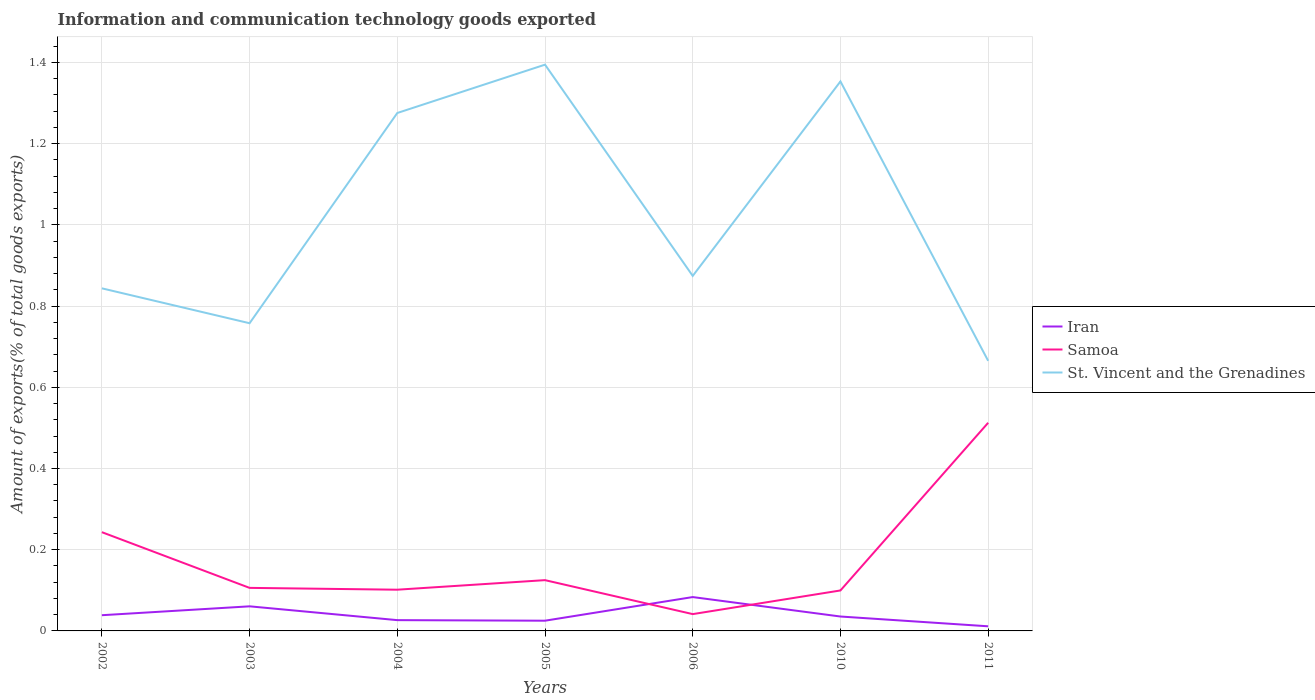How many different coloured lines are there?
Your answer should be compact. 3. Across all years, what is the maximum amount of goods exported in Samoa?
Your answer should be compact. 0.04. In which year was the amount of goods exported in Iran maximum?
Offer a terse response. 2011. What is the total amount of goods exported in St. Vincent and the Grenadines in the graph?
Offer a terse response. -0.12. What is the difference between the highest and the second highest amount of goods exported in Samoa?
Offer a terse response. 0.47. What is the difference between the highest and the lowest amount of goods exported in St. Vincent and the Grenadines?
Make the answer very short. 3. How many lines are there?
Offer a terse response. 3. How many years are there in the graph?
Give a very brief answer. 7. Are the values on the major ticks of Y-axis written in scientific E-notation?
Give a very brief answer. No. What is the title of the graph?
Your response must be concise. Information and communication technology goods exported. Does "Bermuda" appear as one of the legend labels in the graph?
Offer a very short reply. No. What is the label or title of the Y-axis?
Give a very brief answer. Amount of exports(% of total goods exports). What is the Amount of exports(% of total goods exports) of Iran in 2002?
Give a very brief answer. 0.04. What is the Amount of exports(% of total goods exports) in Samoa in 2002?
Your answer should be very brief. 0.24. What is the Amount of exports(% of total goods exports) of St. Vincent and the Grenadines in 2002?
Your answer should be very brief. 0.84. What is the Amount of exports(% of total goods exports) of Iran in 2003?
Keep it short and to the point. 0.06. What is the Amount of exports(% of total goods exports) of Samoa in 2003?
Your response must be concise. 0.11. What is the Amount of exports(% of total goods exports) of St. Vincent and the Grenadines in 2003?
Your response must be concise. 0.76. What is the Amount of exports(% of total goods exports) in Iran in 2004?
Provide a short and direct response. 0.03. What is the Amount of exports(% of total goods exports) in Samoa in 2004?
Make the answer very short. 0.1. What is the Amount of exports(% of total goods exports) in St. Vincent and the Grenadines in 2004?
Provide a short and direct response. 1.28. What is the Amount of exports(% of total goods exports) in Iran in 2005?
Make the answer very short. 0.03. What is the Amount of exports(% of total goods exports) of Samoa in 2005?
Provide a succinct answer. 0.13. What is the Amount of exports(% of total goods exports) in St. Vincent and the Grenadines in 2005?
Offer a very short reply. 1.39. What is the Amount of exports(% of total goods exports) of Iran in 2006?
Give a very brief answer. 0.08. What is the Amount of exports(% of total goods exports) in Samoa in 2006?
Provide a short and direct response. 0.04. What is the Amount of exports(% of total goods exports) in St. Vincent and the Grenadines in 2006?
Your response must be concise. 0.87. What is the Amount of exports(% of total goods exports) of Iran in 2010?
Keep it short and to the point. 0.04. What is the Amount of exports(% of total goods exports) in Samoa in 2010?
Make the answer very short. 0.1. What is the Amount of exports(% of total goods exports) of St. Vincent and the Grenadines in 2010?
Offer a very short reply. 1.35. What is the Amount of exports(% of total goods exports) of Iran in 2011?
Offer a terse response. 0.01. What is the Amount of exports(% of total goods exports) in Samoa in 2011?
Ensure brevity in your answer.  0.51. What is the Amount of exports(% of total goods exports) of St. Vincent and the Grenadines in 2011?
Offer a terse response. 0.67. Across all years, what is the maximum Amount of exports(% of total goods exports) of Iran?
Provide a short and direct response. 0.08. Across all years, what is the maximum Amount of exports(% of total goods exports) in Samoa?
Offer a terse response. 0.51. Across all years, what is the maximum Amount of exports(% of total goods exports) of St. Vincent and the Grenadines?
Give a very brief answer. 1.39. Across all years, what is the minimum Amount of exports(% of total goods exports) in Iran?
Your answer should be very brief. 0.01. Across all years, what is the minimum Amount of exports(% of total goods exports) in Samoa?
Keep it short and to the point. 0.04. Across all years, what is the minimum Amount of exports(% of total goods exports) in St. Vincent and the Grenadines?
Give a very brief answer. 0.67. What is the total Amount of exports(% of total goods exports) of Iran in the graph?
Make the answer very short. 0.28. What is the total Amount of exports(% of total goods exports) of Samoa in the graph?
Offer a terse response. 1.23. What is the total Amount of exports(% of total goods exports) in St. Vincent and the Grenadines in the graph?
Your answer should be very brief. 7.16. What is the difference between the Amount of exports(% of total goods exports) of Iran in 2002 and that in 2003?
Make the answer very short. -0.02. What is the difference between the Amount of exports(% of total goods exports) in Samoa in 2002 and that in 2003?
Provide a succinct answer. 0.14. What is the difference between the Amount of exports(% of total goods exports) in St. Vincent and the Grenadines in 2002 and that in 2003?
Offer a terse response. 0.09. What is the difference between the Amount of exports(% of total goods exports) of Iran in 2002 and that in 2004?
Your answer should be very brief. 0.01. What is the difference between the Amount of exports(% of total goods exports) of Samoa in 2002 and that in 2004?
Keep it short and to the point. 0.14. What is the difference between the Amount of exports(% of total goods exports) of St. Vincent and the Grenadines in 2002 and that in 2004?
Offer a very short reply. -0.43. What is the difference between the Amount of exports(% of total goods exports) in Iran in 2002 and that in 2005?
Give a very brief answer. 0.01. What is the difference between the Amount of exports(% of total goods exports) in Samoa in 2002 and that in 2005?
Your answer should be compact. 0.12. What is the difference between the Amount of exports(% of total goods exports) of St. Vincent and the Grenadines in 2002 and that in 2005?
Offer a terse response. -0.55. What is the difference between the Amount of exports(% of total goods exports) of Iran in 2002 and that in 2006?
Provide a short and direct response. -0.04. What is the difference between the Amount of exports(% of total goods exports) of Samoa in 2002 and that in 2006?
Your answer should be very brief. 0.2. What is the difference between the Amount of exports(% of total goods exports) in St. Vincent and the Grenadines in 2002 and that in 2006?
Offer a very short reply. -0.03. What is the difference between the Amount of exports(% of total goods exports) in Iran in 2002 and that in 2010?
Your answer should be very brief. 0. What is the difference between the Amount of exports(% of total goods exports) in Samoa in 2002 and that in 2010?
Keep it short and to the point. 0.14. What is the difference between the Amount of exports(% of total goods exports) of St. Vincent and the Grenadines in 2002 and that in 2010?
Offer a very short reply. -0.51. What is the difference between the Amount of exports(% of total goods exports) in Iran in 2002 and that in 2011?
Keep it short and to the point. 0.03. What is the difference between the Amount of exports(% of total goods exports) in Samoa in 2002 and that in 2011?
Provide a succinct answer. -0.27. What is the difference between the Amount of exports(% of total goods exports) of St. Vincent and the Grenadines in 2002 and that in 2011?
Ensure brevity in your answer.  0.18. What is the difference between the Amount of exports(% of total goods exports) in Iran in 2003 and that in 2004?
Give a very brief answer. 0.03. What is the difference between the Amount of exports(% of total goods exports) of Samoa in 2003 and that in 2004?
Your response must be concise. 0. What is the difference between the Amount of exports(% of total goods exports) in St. Vincent and the Grenadines in 2003 and that in 2004?
Provide a short and direct response. -0.52. What is the difference between the Amount of exports(% of total goods exports) of Iran in 2003 and that in 2005?
Make the answer very short. 0.04. What is the difference between the Amount of exports(% of total goods exports) of Samoa in 2003 and that in 2005?
Your answer should be very brief. -0.02. What is the difference between the Amount of exports(% of total goods exports) in St. Vincent and the Grenadines in 2003 and that in 2005?
Offer a very short reply. -0.64. What is the difference between the Amount of exports(% of total goods exports) in Iran in 2003 and that in 2006?
Ensure brevity in your answer.  -0.02. What is the difference between the Amount of exports(% of total goods exports) of Samoa in 2003 and that in 2006?
Your response must be concise. 0.06. What is the difference between the Amount of exports(% of total goods exports) of St. Vincent and the Grenadines in 2003 and that in 2006?
Keep it short and to the point. -0.12. What is the difference between the Amount of exports(% of total goods exports) in Iran in 2003 and that in 2010?
Provide a succinct answer. 0.03. What is the difference between the Amount of exports(% of total goods exports) of Samoa in 2003 and that in 2010?
Make the answer very short. 0.01. What is the difference between the Amount of exports(% of total goods exports) in St. Vincent and the Grenadines in 2003 and that in 2010?
Ensure brevity in your answer.  -0.6. What is the difference between the Amount of exports(% of total goods exports) of Iran in 2003 and that in 2011?
Give a very brief answer. 0.05. What is the difference between the Amount of exports(% of total goods exports) of Samoa in 2003 and that in 2011?
Give a very brief answer. -0.41. What is the difference between the Amount of exports(% of total goods exports) in St. Vincent and the Grenadines in 2003 and that in 2011?
Offer a terse response. 0.09. What is the difference between the Amount of exports(% of total goods exports) of Iran in 2004 and that in 2005?
Your response must be concise. 0. What is the difference between the Amount of exports(% of total goods exports) of Samoa in 2004 and that in 2005?
Give a very brief answer. -0.02. What is the difference between the Amount of exports(% of total goods exports) of St. Vincent and the Grenadines in 2004 and that in 2005?
Ensure brevity in your answer.  -0.12. What is the difference between the Amount of exports(% of total goods exports) of Iran in 2004 and that in 2006?
Give a very brief answer. -0.06. What is the difference between the Amount of exports(% of total goods exports) of Samoa in 2004 and that in 2006?
Offer a terse response. 0.06. What is the difference between the Amount of exports(% of total goods exports) of St. Vincent and the Grenadines in 2004 and that in 2006?
Keep it short and to the point. 0.4. What is the difference between the Amount of exports(% of total goods exports) in Iran in 2004 and that in 2010?
Offer a very short reply. -0.01. What is the difference between the Amount of exports(% of total goods exports) in Samoa in 2004 and that in 2010?
Your response must be concise. 0. What is the difference between the Amount of exports(% of total goods exports) in St. Vincent and the Grenadines in 2004 and that in 2010?
Ensure brevity in your answer.  -0.08. What is the difference between the Amount of exports(% of total goods exports) of Iran in 2004 and that in 2011?
Give a very brief answer. 0.02. What is the difference between the Amount of exports(% of total goods exports) in Samoa in 2004 and that in 2011?
Offer a terse response. -0.41. What is the difference between the Amount of exports(% of total goods exports) in St. Vincent and the Grenadines in 2004 and that in 2011?
Give a very brief answer. 0.61. What is the difference between the Amount of exports(% of total goods exports) in Iran in 2005 and that in 2006?
Offer a terse response. -0.06. What is the difference between the Amount of exports(% of total goods exports) of Samoa in 2005 and that in 2006?
Give a very brief answer. 0.08. What is the difference between the Amount of exports(% of total goods exports) in St. Vincent and the Grenadines in 2005 and that in 2006?
Make the answer very short. 0.52. What is the difference between the Amount of exports(% of total goods exports) of Iran in 2005 and that in 2010?
Provide a short and direct response. -0.01. What is the difference between the Amount of exports(% of total goods exports) of Samoa in 2005 and that in 2010?
Your response must be concise. 0.03. What is the difference between the Amount of exports(% of total goods exports) in St. Vincent and the Grenadines in 2005 and that in 2010?
Make the answer very short. 0.04. What is the difference between the Amount of exports(% of total goods exports) of Iran in 2005 and that in 2011?
Ensure brevity in your answer.  0.01. What is the difference between the Amount of exports(% of total goods exports) in Samoa in 2005 and that in 2011?
Keep it short and to the point. -0.39. What is the difference between the Amount of exports(% of total goods exports) of St. Vincent and the Grenadines in 2005 and that in 2011?
Your answer should be very brief. 0.73. What is the difference between the Amount of exports(% of total goods exports) of Iran in 2006 and that in 2010?
Provide a succinct answer. 0.05. What is the difference between the Amount of exports(% of total goods exports) of Samoa in 2006 and that in 2010?
Offer a terse response. -0.06. What is the difference between the Amount of exports(% of total goods exports) in St. Vincent and the Grenadines in 2006 and that in 2010?
Your answer should be compact. -0.48. What is the difference between the Amount of exports(% of total goods exports) in Iran in 2006 and that in 2011?
Your answer should be very brief. 0.07. What is the difference between the Amount of exports(% of total goods exports) in Samoa in 2006 and that in 2011?
Your answer should be compact. -0.47. What is the difference between the Amount of exports(% of total goods exports) in St. Vincent and the Grenadines in 2006 and that in 2011?
Provide a succinct answer. 0.21. What is the difference between the Amount of exports(% of total goods exports) of Iran in 2010 and that in 2011?
Offer a terse response. 0.02. What is the difference between the Amount of exports(% of total goods exports) in Samoa in 2010 and that in 2011?
Provide a short and direct response. -0.41. What is the difference between the Amount of exports(% of total goods exports) of St. Vincent and the Grenadines in 2010 and that in 2011?
Provide a short and direct response. 0.69. What is the difference between the Amount of exports(% of total goods exports) in Iran in 2002 and the Amount of exports(% of total goods exports) in Samoa in 2003?
Your response must be concise. -0.07. What is the difference between the Amount of exports(% of total goods exports) in Iran in 2002 and the Amount of exports(% of total goods exports) in St. Vincent and the Grenadines in 2003?
Provide a short and direct response. -0.72. What is the difference between the Amount of exports(% of total goods exports) in Samoa in 2002 and the Amount of exports(% of total goods exports) in St. Vincent and the Grenadines in 2003?
Ensure brevity in your answer.  -0.51. What is the difference between the Amount of exports(% of total goods exports) of Iran in 2002 and the Amount of exports(% of total goods exports) of Samoa in 2004?
Offer a terse response. -0.06. What is the difference between the Amount of exports(% of total goods exports) of Iran in 2002 and the Amount of exports(% of total goods exports) of St. Vincent and the Grenadines in 2004?
Keep it short and to the point. -1.24. What is the difference between the Amount of exports(% of total goods exports) in Samoa in 2002 and the Amount of exports(% of total goods exports) in St. Vincent and the Grenadines in 2004?
Offer a very short reply. -1.03. What is the difference between the Amount of exports(% of total goods exports) in Iran in 2002 and the Amount of exports(% of total goods exports) in Samoa in 2005?
Your answer should be very brief. -0.09. What is the difference between the Amount of exports(% of total goods exports) of Iran in 2002 and the Amount of exports(% of total goods exports) of St. Vincent and the Grenadines in 2005?
Provide a succinct answer. -1.36. What is the difference between the Amount of exports(% of total goods exports) of Samoa in 2002 and the Amount of exports(% of total goods exports) of St. Vincent and the Grenadines in 2005?
Ensure brevity in your answer.  -1.15. What is the difference between the Amount of exports(% of total goods exports) of Iran in 2002 and the Amount of exports(% of total goods exports) of Samoa in 2006?
Provide a succinct answer. -0. What is the difference between the Amount of exports(% of total goods exports) of Iran in 2002 and the Amount of exports(% of total goods exports) of St. Vincent and the Grenadines in 2006?
Offer a very short reply. -0.84. What is the difference between the Amount of exports(% of total goods exports) in Samoa in 2002 and the Amount of exports(% of total goods exports) in St. Vincent and the Grenadines in 2006?
Give a very brief answer. -0.63. What is the difference between the Amount of exports(% of total goods exports) in Iran in 2002 and the Amount of exports(% of total goods exports) in Samoa in 2010?
Ensure brevity in your answer.  -0.06. What is the difference between the Amount of exports(% of total goods exports) of Iran in 2002 and the Amount of exports(% of total goods exports) of St. Vincent and the Grenadines in 2010?
Keep it short and to the point. -1.31. What is the difference between the Amount of exports(% of total goods exports) of Samoa in 2002 and the Amount of exports(% of total goods exports) of St. Vincent and the Grenadines in 2010?
Offer a very short reply. -1.11. What is the difference between the Amount of exports(% of total goods exports) in Iran in 2002 and the Amount of exports(% of total goods exports) in Samoa in 2011?
Ensure brevity in your answer.  -0.47. What is the difference between the Amount of exports(% of total goods exports) of Iran in 2002 and the Amount of exports(% of total goods exports) of St. Vincent and the Grenadines in 2011?
Provide a succinct answer. -0.63. What is the difference between the Amount of exports(% of total goods exports) of Samoa in 2002 and the Amount of exports(% of total goods exports) of St. Vincent and the Grenadines in 2011?
Ensure brevity in your answer.  -0.42. What is the difference between the Amount of exports(% of total goods exports) of Iran in 2003 and the Amount of exports(% of total goods exports) of Samoa in 2004?
Keep it short and to the point. -0.04. What is the difference between the Amount of exports(% of total goods exports) of Iran in 2003 and the Amount of exports(% of total goods exports) of St. Vincent and the Grenadines in 2004?
Your answer should be compact. -1.21. What is the difference between the Amount of exports(% of total goods exports) in Samoa in 2003 and the Amount of exports(% of total goods exports) in St. Vincent and the Grenadines in 2004?
Your response must be concise. -1.17. What is the difference between the Amount of exports(% of total goods exports) of Iran in 2003 and the Amount of exports(% of total goods exports) of Samoa in 2005?
Provide a short and direct response. -0.06. What is the difference between the Amount of exports(% of total goods exports) of Iran in 2003 and the Amount of exports(% of total goods exports) of St. Vincent and the Grenadines in 2005?
Ensure brevity in your answer.  -1.33. What is the difference between the Amount of exports(% of total goods exports) of Samoa in 2003 and the Amount of exports(% of total goods exports) of St. Vincent and the Grenadines in 2005?
Provide a succinct answer. -1.29. What is the difference between the Amount of exports(% of total goods exports) of Iran in 2003 and the Amount of exports(% of total goods exports) of Samoa in 2006?
Offer a terse response. 0.02. What is the difference between the Amount of exports(% of total goods exports) in Iran in 2003 and the Amount of exports(% of total goods exports) in St. Vincent and the Grenadines in 2006?
Make the answer very short. -0.81. What is the difference between the Amount of exports(% of total goods exports) of Samoa in 2003 and the Amount of exports(% of total goods exports) of St. Vincent and the Grenadines in 2006?
Ensure brevity in your answer.  -0.77. What is the difference between the Amount of exports(% of total goods exports) in Iran in 2003 and the Amount of exports(% of total goods exports) in Samoa in 2010?
Make the answer very short. -0.04. What is the difference between the Amount of exports(% of total goods exports) in Iran in 2003 and the Amount of exports(% of total goods exports) in St. Vincent and the Grenadines in 2010?
Provide a short and direct response. -1.29. What is the difference between the Amount of exports(% of total goods exports) in Samoa in 2003 and the Amount of exports(% of total goods exports) in St. Vincent and the Grenadines in 2010?
Ensure brevity in your answer.  -1.25. What is the difference between the Amount of exports(% of total goods exports) of Iran in 2003 and the Amount of exports(% of total goods exports) of Samoa in 2011?
Make the answer very short. -0.45. What is the difference between the Amount of exports(% of total goods exports) of Iran in 2003 and the Amount of exports(% of total goods exports) of St. Vincent and the Grenadines in 2011?
Make the answer very short. -0.6. What is the difference between the Amount of exports(% of total goods exports) in Samoa in 2003 and the Amount of exports(% of total goods exports) in St. Vincent and the Grenadines in 2011?
Your answer should be very brief. -0.56. What is the difference between the Amount of exports(% of total goods exports) in Iran in 2004 and the Amount of exports(% of total goods exports) in Samoa in 2005?
Your response must be concise. -0.1. What is the difference between the Amount of exports(% of total goods exports) of Iran in 2004 and the Amount of exports(% of total goods exports) of St. Vincent and the Grenadines in 2005?
Keep it short and to the point. -1.37. What is the difference between the Amount of exports(% of total goods exports) of Samoa in 2004 and the Amount of exports(% of total goods exports) of St. Vincent and the Grenadines in 2005?
Provide a short and direct response. -1.29. What is the difference between the Amount of exports(% of total goods exports) in Iran in 2004 and the Amount of exports(% of total goods exports) in Samoa in 2006?
Your answer should be very brief. -0.01. What is the difference between the Amount of exports(% of total goods exports) in Iran in 2004 and the Amount of exports(% of total goods exports) in St. Vincent and the Grenadines in 2006?
Your answer should be compact. -0.85. What is the difference between the Amount of exports(% of total goods exports) of Samoa in 2004 and the Amount of exports(% of total goods exports) of St. Vincent and the Grenadines in 2006?
Give a very brief answer. -0.77. What is the difference between the Amount of exports(% of total goods exports) in Iran in 2004 and the Amount of exports(% of total goods exports) in Samoa in 2010?
Your answer should be very brief. -0.07. What is the difference between the Amount of exports(% of total goods exports) of Iran in 2004 and the Amount of exports(% of total goods exports) of St. Vincent and the Grenadines in 2010?
Offer a very short reply. -1.33. What is the difference between the Amount of exports(% of total goods exports) of Samoa in 2004 and the Amount of exports(% of total goods exports) of St. Vincent and the Grenadines in 2010?
Give a very brief answer. -1.25. What is the difference between the Amount of exports(% of total goods exports) in Iran in 2004 and the Amount of exports(% of total goods exports) in Samoa in 2011?
Give a very brief answer. -0.49. What is the difference between the Amount of exports(% of total goods exports) in Iran in 2004 and the Amount of exports(% of total goods exports) in St. Vincent and the Grenadines in 2011?
Give a very brief answer. -0.64. What is the difference between the Amount of exports(% of total goods exports) in Samoa in 2004 and the Amount of exports(% of total goods exports) in St. Vincent and the Grenadines in 2011?
Your response must be concise. -0.56. What is the difference between the Amount of exports(% of total goods exports) in Iran in 2005 and the Amount of exports(% of total goods exports) in Samoa in 2006?
Offer a terse response. -0.02. What is the difference between the Amount of exports(% of total goods exports) in Iran in 2005 and the Amount of exports(% of total goods exports) in St. Vincent and the Grenadines in 2006?
Your answer should be compact. -0.85. What is the difference between the Amount of exports(% of total goods exports) in Samoa in 2005 and the Amount of exports(% of total goods exports) in St. Vincent and the Grenadines in 2006?
Make the answer very short. -0.75. What is the difference between the Amount of exports(% of total goods exports) in Iran in 2005 and the Amount of exports(% of total goods exports) in Samoa in 2010?
Offer a terse response. -0.07. What is the difference between the Amount of exports(% of total goods exports) in Iran in 2005 and the Amount of exports(% of total goods exports) in St. Vincent and the Grenadines in 2010?
Your response must be concise. -1.33. What is the difference between the Amount of exports(% of total goods exports) in Samoa in 2005 and the Amount of exports(% of total goods exports) in St. Vincent and the Grenadines in 2010?
Make the answer very short. -1.23. What is the difference between the Amount of exports(% of total goods exports) in Iran in 2005 and the Amount of exports(% of total goods exports) in Samoa in 2011?
Offer a very short reply. -0.49. What is the difference between the Amount of exports(% of total goods exports) in Iran in 2005 and the Amount of exports(% of total goods exports) in St. Vincent and the Grenadines in 2011?
Offer a terse response. -0.64. What is the difference between the Amount of exports(% of total goods exports) in Samoa in 2005 and the Amount of exports(% of total goods exports) in St. Vincent and the Grenadines in 2011?
Keep it short and to the point. -0.54. What is the difference between the Amount of exports(% of total goods exports) in Iran in 2006 and the Amount of exports(% of total goods exports) in Samoa in 2010?
Offer a very short reply. -0.02. What is the difference between the Amount of exports(% of total goods exports) in Iran in 2006 and the Amount of exports(% of total goods exports) in St. Vincent and the Grenadines in 2010?
Ensure brevity in your answer.  -1.27. What is the difference between the Amount of exports(% of total goods exports) in Samoa in 2006 and the Amount of exports(% of total goods exports) in St. Vincent and the Grenadines in 2010?
Your response must be concise. -1.31. What is the difference between the Amount of exports(% of total goods exports) in Iran in 2006 and the Amount of exports(% of total goods exports) in Samoa in 2011?
Ensure brevity in your answer.  -0.43. What is the difference between the Amount of exports(% of total goods exports) of Iran in 2006 and the Amount of exports(% of total goods exports) of St. Vincent and the Grenadines in 2011?
Your response must be concise. -0.58. What is the difference between the Amount of exports(% of total goods exports) of Samoa in 2006 and the Amount of exports(% of total goods exports) of St. Vincent and the Grenadines in 2011?
Provide a succinct answer. -0.62. What is the difference between the Amount of exports(% of total goods exports) of Iran in 2010 and the Amount of exports(% of total goods exports) of Samoa in 2011?
Keep it short and to the point. -0.48. What is the difference between the Amount of exports(% of total goods exports) of Iran in 2010 and the Amount of exports(% of total goods exports) of St. Vincent and the Grenadines in 2011?
Your answer should be compact. -0.63. What is the difference between the Amount of exports(% of total goods exports) in Samoa in 2010 and the Amount of exports(% of total goods exports) in St. Vincent and the Grenadines in 2011?
Your response must be concise. -0.57. What is the average Amount of exports(% of total goods exports) of Iran per year?
Provide a short and direct response. 0.04. What is the average Amount of exports(% of total goods exports) in Samoa per year?
Your answer should be very brief. 0.18. What is the average Amount of exports(% of total goods exports) in St. Vincent and the Grenadines per year?
Give a very brief answer. 1.02. In the year 2002, what is the difference between the Amount of exports(% of total goods exports) of Iran and Amount of exports(% of total goods exports) of Samoa?
Make the answer very short. -0.2. In the year 2002, what is the difference between the Amount of exports(% of total goods exports) of Iran and Amount of exports(% of total goods exports) of St. Vincent and the Grenadines?
Keep it short and to the point. -0.81. In the year 2002, what is the difference between the Amount of exports(% of total goods exports) of Samoa and Amount of exports(% of total goods exports) of St. Vincent and the Grenadines?
Give a very brief answer. -0.6. In the year 2003, what is the difference between the Amount of exports(% of total goods exports) of Iran and Amount of exports(% of total goods exports) of Samoa?
Offer a terse response. -0.05. In the year 2003, what is the difference between the Amount of exports(% of total goods exports) of Iran and Amount of exports(% of total goods exports) of St. Vincent and the Grenadines?
Ensure brevity in your answer.  -0.7. In the year 2003, what is the difference between the Amount of exports(% of total goods exports) in Samoa and Amount of exports(% of total goods exports) in St. Vincent and the Grenadines?
Provide a short and direct response. -0.65. In the year 2004, what is the difference between the Amount of exports(% of total goods exports) in Iran and Amount of exports(% of total goods exports) in Samoa?
Your answer should be compact. -0.07. In the year 2004, what is the difference between the Amount of exports(% of total goods exports) of Iran and Amount of exports(% of total goods exports) of St. Vincent and the Grenadines?
Your response must be concise. -1.25. In the year 2004, what is the difference between the Amount of exports(% of total goods exports) of Samoa and Amount of exports(% of total goods exports) of St. Vincent and the Grenadines?
Provide a short and direct response. -1.17. In the year 2005, what is the difference between the Amount of exports(% of total goods exports) of Iran and Amount of exports(% of total goods exports) of Samoa?
Ensure brevity in your answer.  -0.1. In the year 2005, what is the difference between the Amount of exports(% of total goods exports) of Iran and Amount of exports(% of total goods exports) of St. Vincent and the Grenadines?
Keep it short and to the point. -1.37. In the year 2005, what is the difference between the Amount of exports(% of total goods exports) in Samoa and Amount of exports(% of total goods exports) in St. Vincent and the Grenadines?
Provide a short and direct response. -1.27. In the year 2006, what is the difference between the Amount of exports(% of total goods exports) of Iran and Amount of exports(% of total goods exports) of Samoa?
Provide a short and direct response. 0.04. In the year 2006, what is the difference between the Amount of exports(% of total goods exports) of Iran and Amount of exports(% of total goods exports) of St. Vincent and the Grenadines?
Provide a succinct answer. -0.79. In the year 2006, what is the difference between the Amount of exports(% of total goods exports) in Samoa and Amount of exports(% of total goods exports) in St. Vincent and the Grenadines?
Offer a very short reply. -0.83. In the year 2010, what is the difference between the Amount of exports(% of total goods exports) of Iran and Amount of exports(% of total goods exports) of Samoa?
Your response must be concise. -0.06. In the year 2010, what is the difference between the Amount of exports(% of total goods exports) of Iran and Amount of exports(% of total goods exports) of St. Vincent and the Grenadines?
Provide a short and direct response. -1.32. In the year 2010, what is the difference between the Amount of exports(% of total goods exports) of Samoa and Amount of exports(% of total goods exports) of St. Vincent and the Grenadines?
Provide a succinct answer. -1.25. In the year 2011, what is the difference between the Amount of exports(% of total goods exports) in Iran and Amount of exports(% of total goods exports) in Samoa?
Give a very brief answer. -0.5. In the year 2011, what is the difference between the Amount of exports(% of total goods exports) of Iran and Amount of exports(% of total goods exports) of St. Vincent and the Grenadines?
Make the answer very short. -0.65. In the year 2011, what is the difference between the Amount of exports(% of total goods exports) in Samoa and Amount of exports(% of total goods exports) in St. Vincent and the Grenadines?
Offer a very short reply. -0.15. What is the ratio of the Amount of exports(% of total goods exports) of Iran in 2002 to that in 2003?
Provide a succinct answer. 0.64. What is the ratio of the Amount of exports(% of total goods exports) of Samoa in 2002 to that in 2003?
Your answer should be compact. 2.29. What is the ratio of the Amount of exports(% of total goods exports) of St. Vincent and the Grenadines in 2002 to that in 2003?
Give a very brief answer. 1.11. What is the ratio of the Amount of exports(% of total goods exports) in Iran in 2002 to that in 2004?
Your response must be concise. 1.46. What is the ratio of the Amount of exports(% of total goods exports) in Samoa in 2002 to that in 2004?
Your answer should be compact. 2.4. What is the ratio of the Amount of exports(% of total goods exports) in St. Vincent and the Grenadines in 2002 to that in 2004?
Give a very brief answer. 0.66. What is the ratio of the Amount of exports(% of total goods exports) of Iran in 2002 to that in 2005?
Give a very brief answer. 1.54. What is the ratio of the Amount of exports(% of total goods exports) in Samoa in 2002 to that in 2005?
Your answer should be very brief. 1.94. What is the ratio of the Amount of exports(% of total goods exports) of St. Vincent and the Grenadines in 2002 to that in 2005?
Your answer should be very brief. 0.6. What is the ratio of the Amount of exports(% of total goods exports) in Iran in 2002 to that in 2006?
Ensure brevity in your answer.  0.46. What is the ratio of the Amount of exports(% of total goods exports) of Samoa in 2002 to that in 2006?
Your answer should be very brief. 5.87. What is the ratio of the Amount of exports(% of total goods exports) in Iran in 2002 to that in 2010?
Offer a terse response. 1.09. What is the ratio of the Amount of exports(% of total goods exports) in Samoa in 2002 to that in 2010?
Make the answer very short. 2.44. What is the ratio of the Amount of exports(% of total goods exports) of St. Vincent and the Grenadines in 2002 to that in 2010?
Offer a terse response. 0.62. What is the ratio of the Amount of exports(% of total goods exports) of Iran in 2002 to that in 2011?
Provide a succinct answer. 3.4. What is the ratio of the Amount of exports(% of total goods exports) in Samoa in 2002 to that in 2011?
Offer a terse response. 0.47. What is the ratio of the Amount of exports(% of total goods exports) of St. Vincent and the Grenadines in 2002 to that in 2011?
Your response must be concise. 1.27. What is the ratio of the Amount of exports(% of total goods exports) of Iran in 2003 to that in 2004?
Offer a very short reply. 2.28. What is the ratio of the Amount of exports(% of total goods exports) of Samoa in 2003 to that in 2004?
Keep it short and to the point. 1.04. What is the ratio of the Amount of exports(% of total goods exports) of St. Vincent and the Grenadines in 2003 to that in 2004?
Make the answer very short. 0.59. What is the ratio of the Amount of exports(% of total goods exports) in Iran in 2003 to that in 2005?
Give a very brief answer. 2.41. What is the ratio of the Amount of exports(% of total goods exports) in Samoa in 2003 to that in 2005?
Ensure brevity in your answer.  0.85. What is the ratio of the Amount of exports(% of total goods exports) of St. Vincent and the Grenadines in 2003 to that in 2005?
Provide a short and direct response. 0.54. What is the ratio of the Amount of exports(% of total goods exports) of Iran in 2003 to that in 2006?
Ensure brevity in your answer.  0.73. What is the ratio of the Amount of exports(% of total goods exports) of Samoa in 2003 to that in 2006?
Keep it short and to the point. 2.56. What is the ratio of the Amount of exports(% of total goods exports) in St. Vincent and the Grenadines in 2003 to that in 2006?
Offer a very short reply. 0.87. What is the ratio of the Amount of exports(% of total goods exports) of Iran in 2003 to that in 2010?
Give a very brief answer. 1.71. What is the ratio of the Amount of exports(% of total goods exports) of Samoa in 2003 to that in 2010?
Offer a terse response. 1.06. What is the ratio of the Amount of exports(% of total goods exports) of St. Vincent and the Grenadines in 2003 to that in 2010?
Give a very brief answer. 0.56. What is the ratio of the Amount of exports(% of total goods exports) of Iran in 2003 to that in 2011?
Offer a terse response. 5.32. What is the ratio of the Amount of exports(% of total goods exports) of Samoa in 2003 to that in 2011?
Make the answer very short. 0.21. What is the ratio of the Amount of exports(% of total goods exports) of St. Vincent and the Grenadines in 2003 to that in 2011?
Offer a terse response. 1.14. What is the ratio of the Amount of exports(% of total goods exports) in Iran in 2004 to that in 2005?
Your response must be concise. 1.05. What is the ratio of the Amount of exports(% of total goods exports) in Samoa in 2004 to that in 2005?
Make the answer very short. 0.81. What is the ratio of the Amount of exports(% of total goods exports) in St. Vincent and the Grenadines in 2004 to that in 2005?
Offer a terse response. 0.91. What is the ratio of the Amount of exports(% of total goods exports) in Iran in 2004 to that in 2006?
Provide a succinct answer. 0.32. What is the ratio of the Amount of exports(% of total goods exports) in Samoa in 2004 to that in 2006?
Keep it short and to the point. 2.45. What is the ratio of the Amount of exports(% of total goods exports) of St. Vincent and the Grenadines in 2004 to that in 2006?
Provide a succinct answer. 1.46. What is the ratio of the Amount of exports(% of total goods exports) in Iran in 2004 to that in 2010?
Your response must be concise. 0.75. What is the ratio of the Amount of exports(% of total goods exports) of Samoa in 2004 to that in 2010?
Provide a short and direct response. 1.02. What is the ratio of the Amount of exports(% of total goods exports) of St. Vincent and the Grenadines in 2004 to that in 2010?
Provide a succinct answer. 0.94. What is the ratio of the Amount of exports(% of total goods exports) in Iran in 2004 to that in 2011?
Your answer should be compact. 2.33. What is the ratio of the Amount of exports(% of total goods exports) of Samoa in 2004 to that in 2011?
Offer a terse response. 0.2. What is the ratio of the Amount of exports(% of total goods exports) in St. Vincent and the Grenadines in 2004 to that in 2011?
Your response must be concise. 1.92. What is the ratio of the Amount of exports(% of total goods exports) in Iran in 2005 to that in 2006?
Your answer should be very brief. 0.3. What is the ratio of the Amount of exports(% of total goods exports) in Samoa in 2005 to that in 2006?
Provide a succinct answer. 3.02. What is the ratio of the Amount of exports(% of total goods exports) of St. Vincent and the Grenadines in 2005 to that in 2006?
Keep it short and to the point. 1.59. What is the ratio of the Amount of exports(% of total goods exports) in Iran in 2005 to that in 2010?
Your answer should be compact. 0.71. What is the ratio of the Amount of exports(% of total goods exports) of Samoa in 2005 to that in 2010?
Provide a succinct answer. 1.25. What is the ratio of the Amount of exports(% of total goods exports) of St. Vincent and the Grenadines in 2005 to that in 2010?
Offer a terse response. 1.03. What is the ratio of the Amount of exports(% of total goods exports) of Iran in 2005 to that in 2011?
Make the answer very short. 2.21. What is the ratio of the Amount of exports(% of total goods exports) in Samoa in 2005 to that in 2011?
Provide a short and direct response. 0.24. What is the ratio of the Amount of exports(% of total goods exports) of St. Vincent and the Grenadines in 2005 to that in 2011?
Provide a succinct answer. 2.1. What is the ratio of the Amount of exports(% of total goods exports) in Iran in 2006 to that in 2010?
Keep it short and to the point. 2.35. What is the ratio of the Amount of exports(% of total goods exports) in Samoa in 2006 to that in 2010?
Provide a short and direct response. 0.42. What is the ratio of the Amount of exports(% of total goods exports) in St. Vincent and the Grenadines in 2006 to that in 2010?
Ensure brevity in your answer.  0.65. What is the ratio of the Amount of exports(% of total goods exports) of Iran in 2006 to that in 2011?
Make the answer very short. 7.33. What is the ratio of the Amount of exports(% of total goods exports) of Samoa in 2006 to that in 2011?
Your answer should be very brief. 0.08. What is the ratio of the Amount of exports(% of total goods exports) in St. Vincent and the Grenadines in 2006 to that in 2011?
Ensure brevity in your answer.  1.31. What is the ratio of the Amount of exports(% of total goods exports) in Iran in 2010 to that in 2011?
Keep it short and to the point. 3.12. What is the ratio of the Amount of exports(% of total goods exports) of Samoa in 2010 to that in 2011?
Ensure brevity in your answer.  0.19. What is the ratio of the Amount of exports(% of total goods exports) of St. Vincent and the Grenadines in 2010 to that in 2011?
Your response must be concise. 2.03. What is the difference between the highest and the second highest Amount of exports(% of total goods exports) of Iran?
Keep it short and to the point. 0.02. What is the difference between the highest and the second highest Amount of exports(% of total goods exports) of Samoa?
Give a very brief answer. 0.27. What is the difference between the highest and the second highest Amount of exports(% of total goods exports) in St. Vincent and the Grenadines?
Provide a short and direct response. 0.04. What is the difference between the highest and the lowest Amount of exports(% of total goods exports) in Iran?
Give a very brief answer. 0.07. What is the difference between the highest and the lowest Amount of exports(% of total goods exports) of Samoa?
Offer a terse response. 0.47. What is the difference between the highest and the lowest Amount of exports(% of total goods exports) in St. Vincent and the Grenadines?
Offer a very short reply. 0.73. 